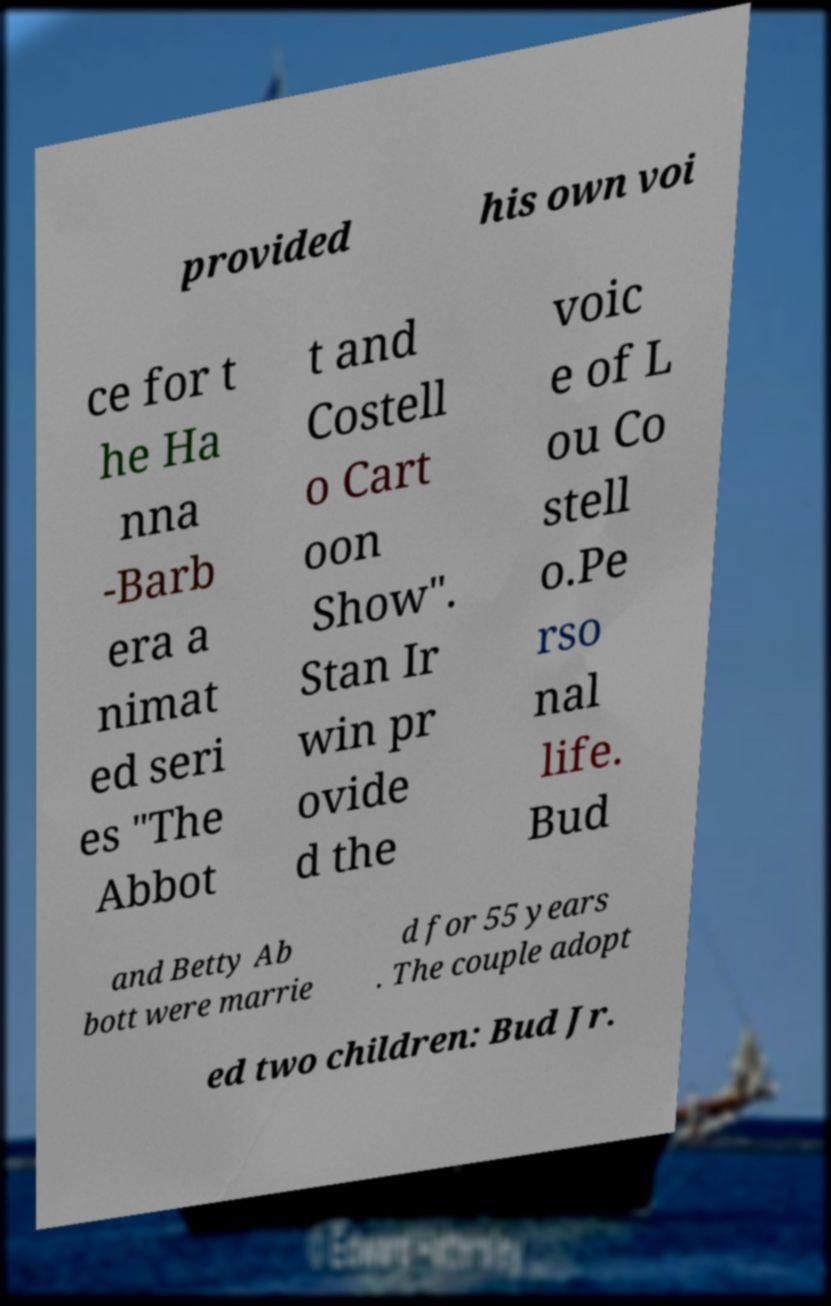Can you read and provide the text displayed in the image?This photo seems to have some interesting text. Can you extract and type it out for me? provided his own voi ce for t he Ha nna -Barb era a nimat ed seri es "The Abbot t and Costell o Cart oon Show". Stan Ir win pr ovide d the voic e of L ou Co stell o.Pe rso nal life. Bud and Betty Ab bott were marrie d for 55 years . The couple adopt ed two children: Bud Jr. 